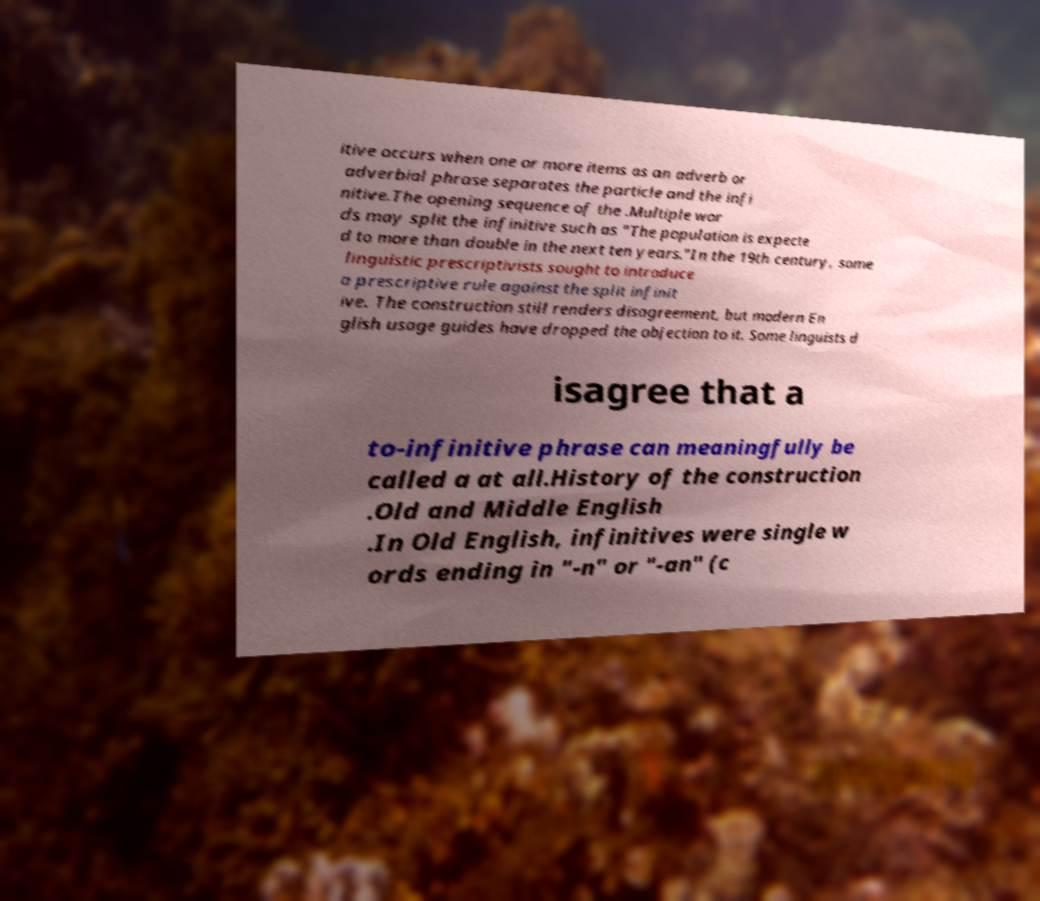Could you assist in decoding the text presented in this image and type it out clearly? itive occurs when one or more items as an adverb or adverbial phrase separates the particle and the infi nitive.The opening sequence of the .Multiple wor ds may split the infinitive such as "The population is expecte d to more than double in the next ten years."In the 19th century, some linguistic prescriptivists sought to introduce a prescriptive rule against the split infinit ive. The construction still renders disagreement, but modern En glish usage guides have dropped the objection to it. Some linguists d isagree that a to-infinitive phrase can meaningfully be called a at all.History of the construction .Old and Middle English .In Old English, infinitives were single w ords ending in "-n" or "-an" (c 